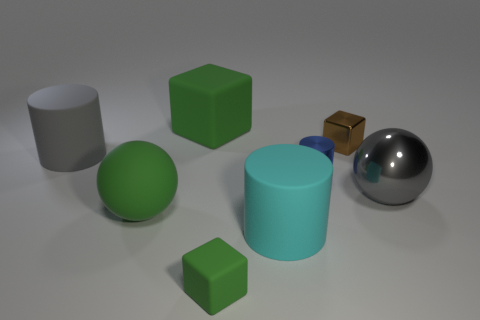Do the large matte cube and the shiny sphere have the same color?
Give a very brief answer. No. There is a large thing that is the same color as the big rubber sphere; what is it made of?
Keep it short and to the point. Rubber. Do the tiny brown thing and the big green rubber object behind the shiny block have the same shape?
Your answer should be very brief. Yes. The sphere that is made of the same material as the big cube is what color?
Offer a terse response. Green. The big shiny thing has what color?
Make the answer very short. Gray. Do the gray sphere and the cube that is right of the small blue shiny object have the same material?
Your answer should be very brief. Yes. What number of big rubber objects are to the right of the big gray rubber thing and behind the tiny blue thing?
Offer a terse response. 1. There is another gray object that is the same size as the gray matte object; what shape is it?
Make the answer very short. Sphere. There is a large matte block that is behind the small block that is behind the large cyan thing; is there a large cyan rubber cylinder to the right of it?
Your answer should be very brief. Yes. There is a big metallic thing; is it the same color as the large cylinder that is behind the large gray metallic thing?
Your answer should be very brief. Yes. 